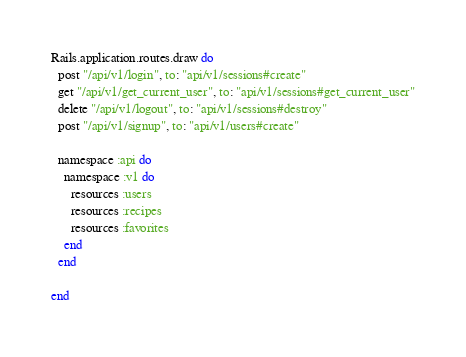<code> <loc_0><loc_0><loc_500><loc_500><_Ruby_>Rails.application.routes.draw do
  post "/api/v1/login", to: "api/v1/sessions#create"
  get "/api/v1/get_current_user", to: "api/v1/sessions#get_current_user"
  delete "/api/v1/logout", to: "api/v1/sessions#destroy"
  post "/api/v1/signup", to: "api/v1/users#create"

  namespace :api do
    namespace :v1 do
      resources :users
      resources :recipes
      resources :favorites
    end
  end
  
end
</code> 